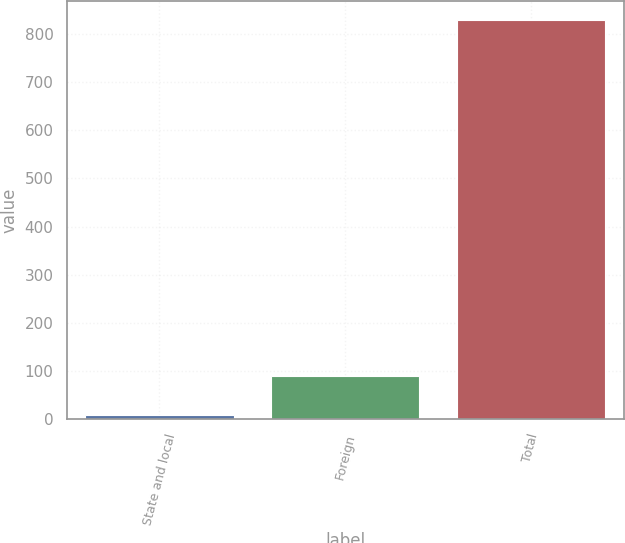Convert chart to OTSL. <chart><loc_0><loc_0><loc_500><loc_500><bar_chart><fcel>State and local<fcel>Foreign<fcel>Total<nl><fcel>8<fcel>90<fcel>828<nl></chart> 